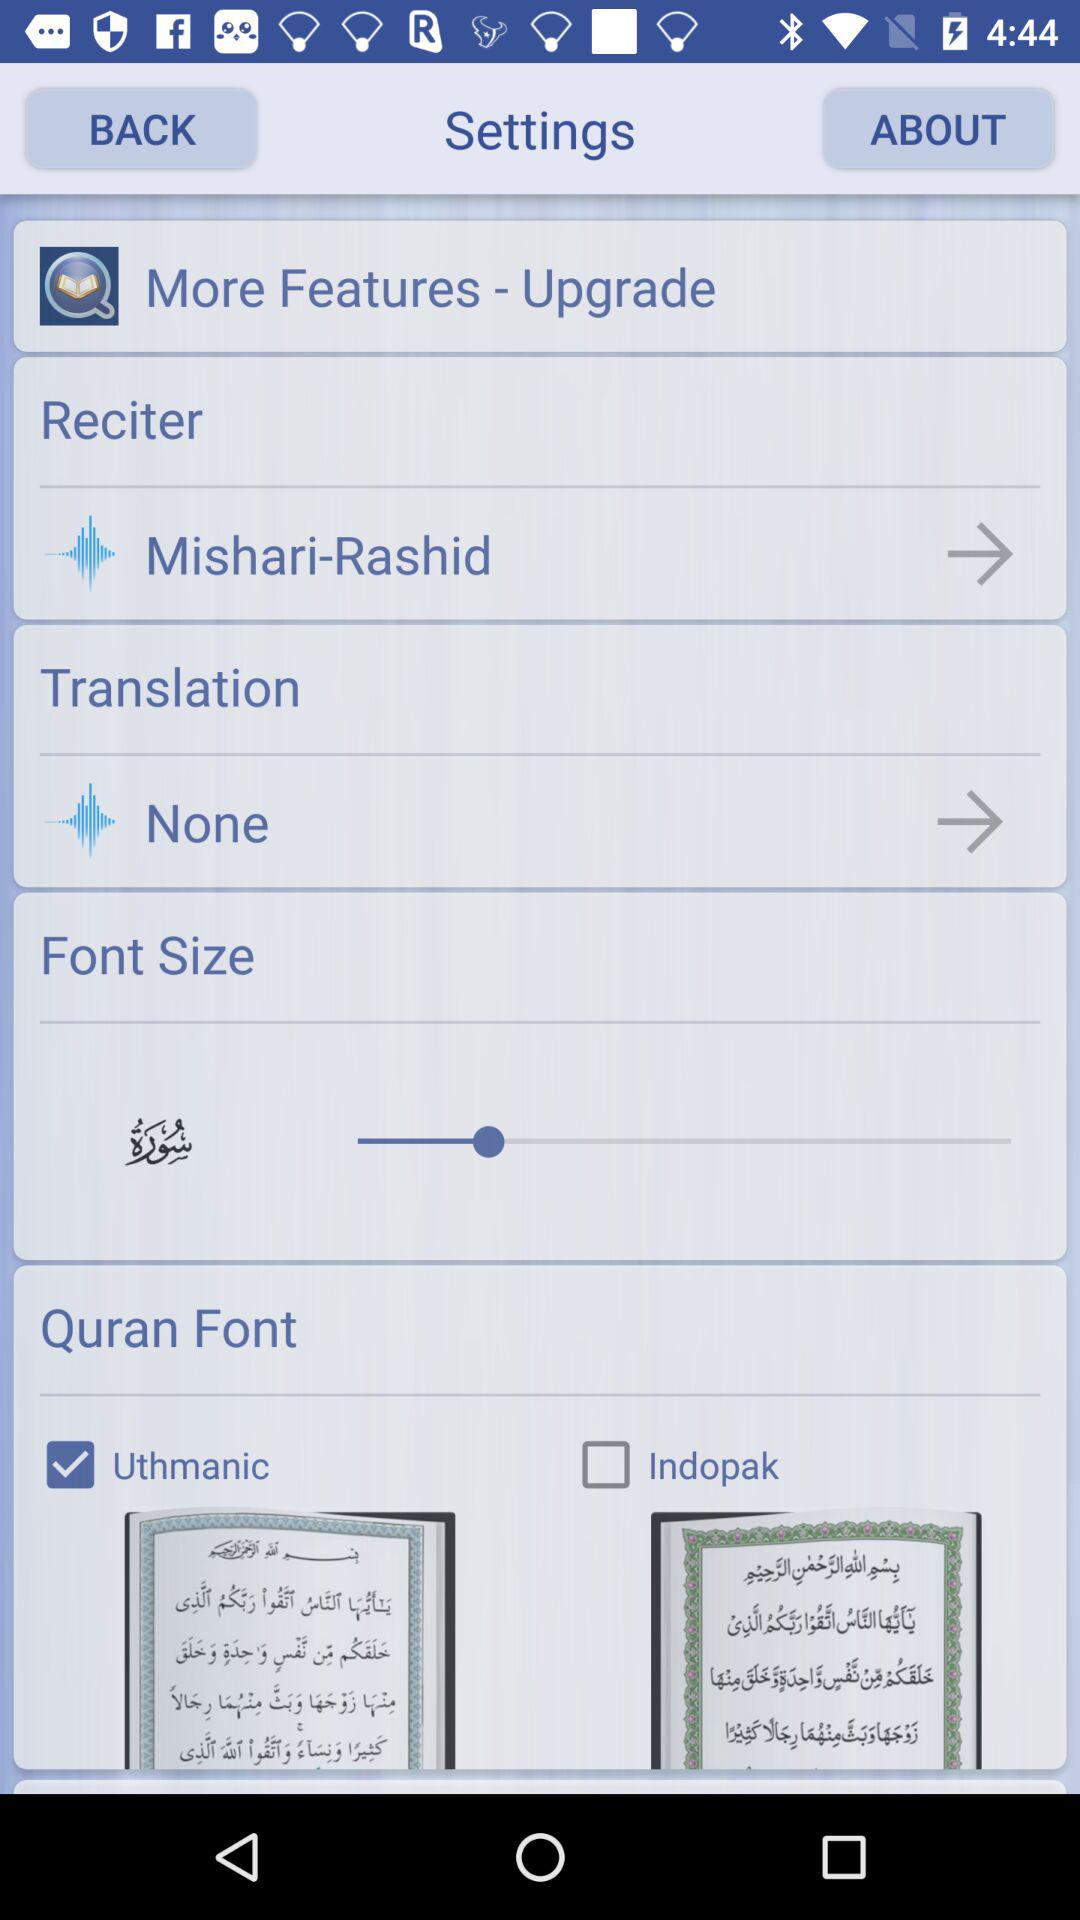What is the checked checkbox? The checked checkbox is "Uthmanic". 